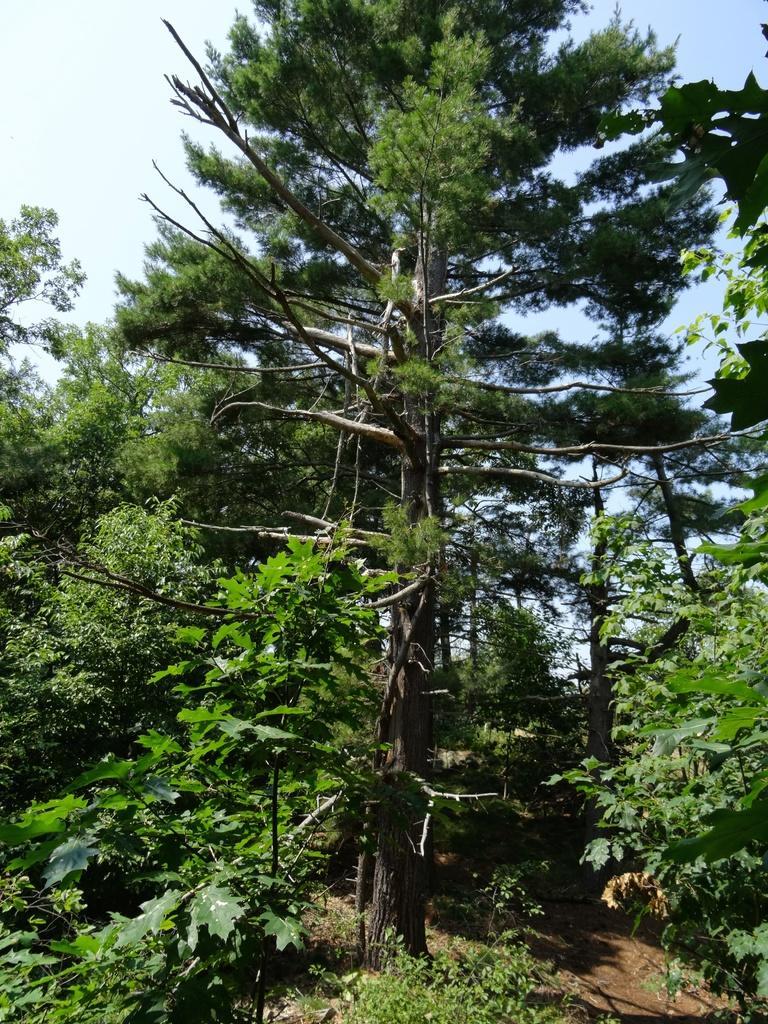What type of vegetation can be seen in the image? There are trees in the image. What is the color of the trees in the image? The trees are green in color. What can be seen in the background of the image? The sky is visible in the background of the image. What colors are present in the sky in the image? The sky is blue and white in color. Where is the chessboard located in the image? There is no chessboard present in the image. What type of vase can be seen on the floor in the image? There is no vase or floor present in the image; it only features trees and the sky. 